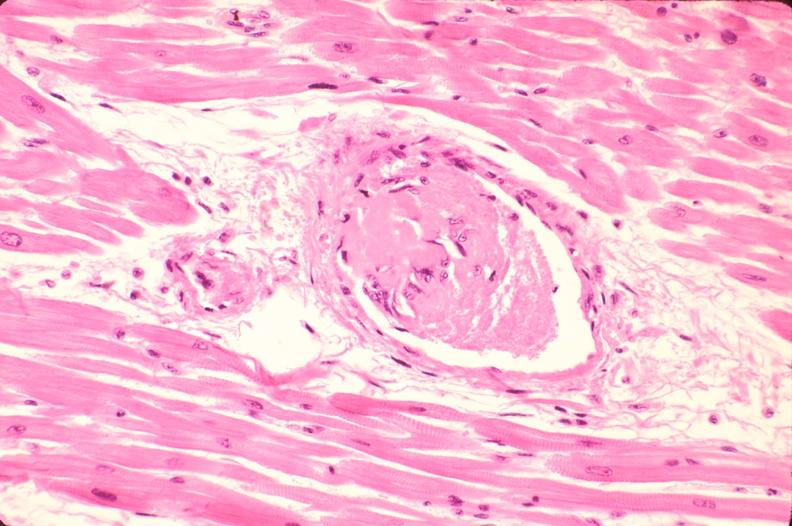where is this in?
Answer the question using a single word or phrase. In heart 